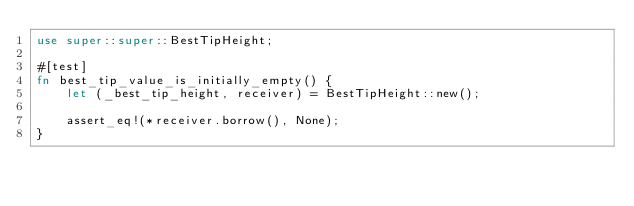<code> <loc_0><loc_0><loc_500><loc_500><_Rust_>use super::super::BestTipHeight;

#[test]
fn best_tip_value_is_initially_empty() {
    let (_best_tip_height, receiver) = BestTipHeight::new();

    assert_eq!(*receiver.borrow(), None);
}
</code> 